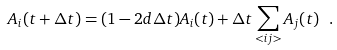<formula> <loc_0><loc_0><loc_500><loc_500>A _ { i } ( t + \Delta t ) = ( 1 - 2 d \Delta t ) A _ { i } ( t ) + \Delta t \sum _ { < i j > } A _ { j } ( t ) \ .</formula> 